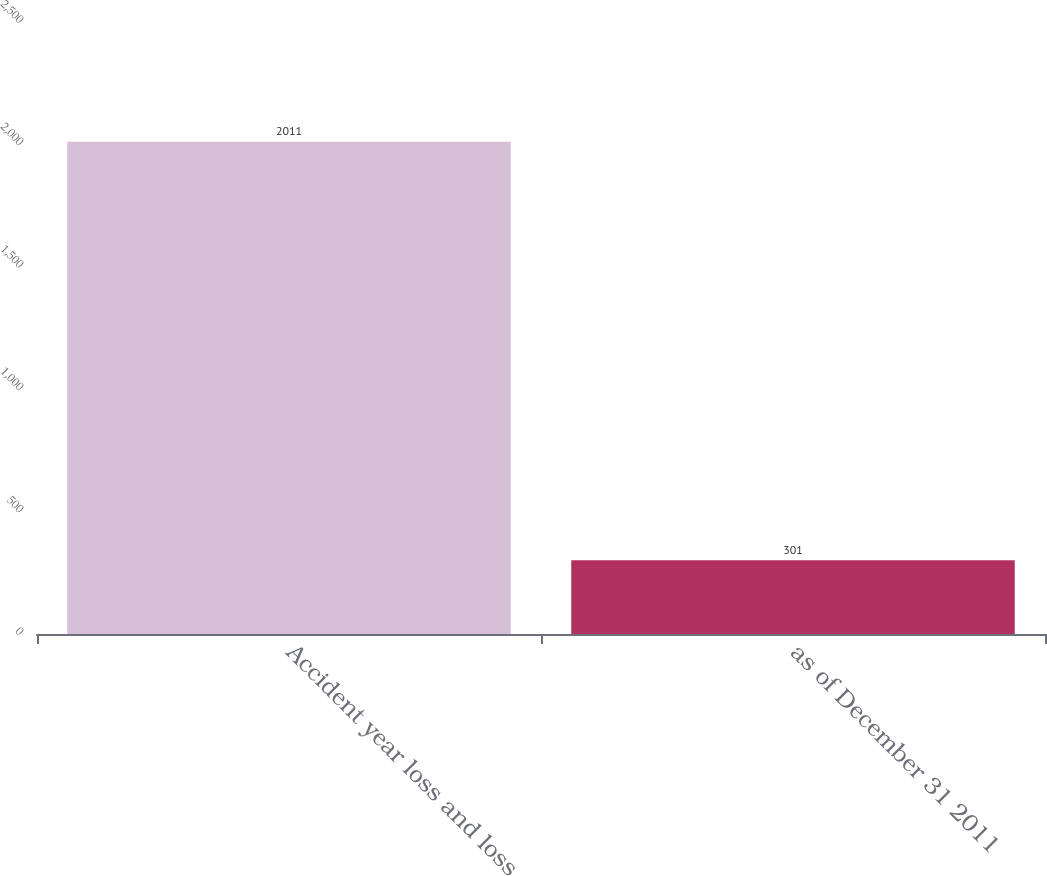Convert chart. <chart><loc_0><loc_0><loc_500><loc_500><bar_chart><fcel>Accident year loss and loss<fcel>as of December 31 2011<nl><fcel>2011<fcel>301<nl></chart> 